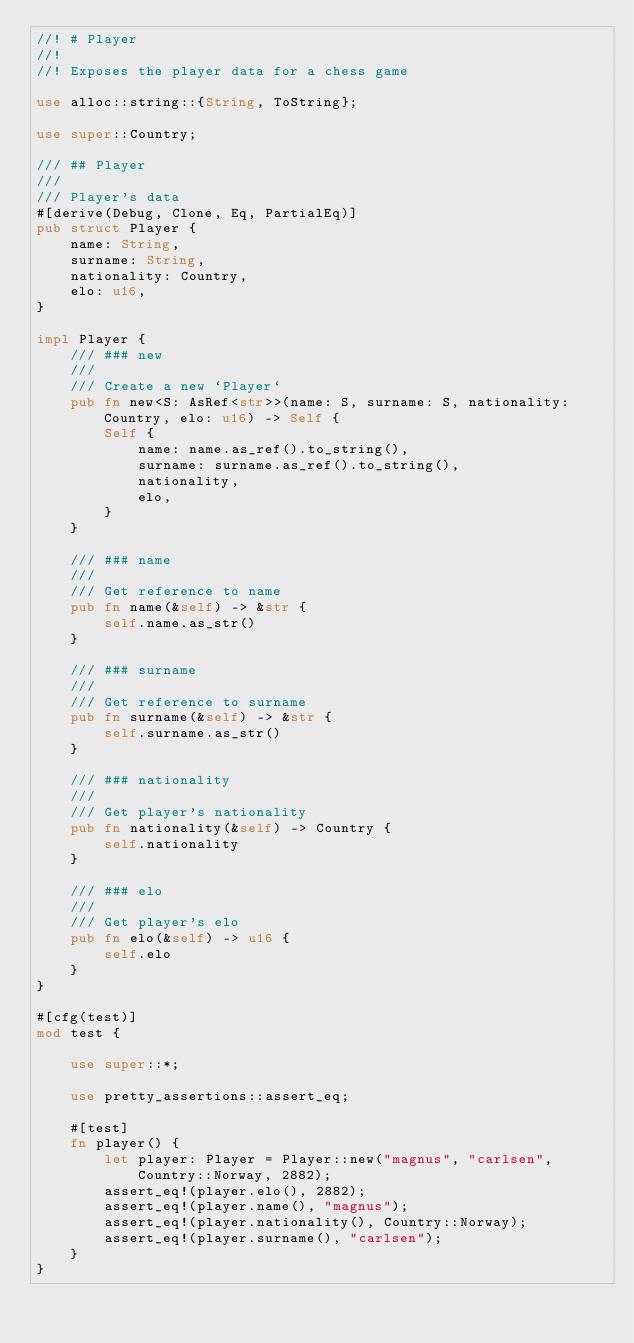Convert code to text. <code><loc_0><loc_0><loc_500><loc_500><_Rust_>//! # Player
//!
//! Exposes the player data for a chess game

use alloc::string::{String, ToString};

use super::Country;

/// ## Player
///
/// Player's data
#[derive(Debug, Clone, Eq, PartialEq)]
pub struct Player {
    name: String,
    surname: String,
    nationality: Country,
    elo: u16,
}

impl Player {
    /// ### new
    ///
    /// Create a new `Player`
    pub fn new<S: AsRef<str>>(name: S, surname: S, nationality: Country, elo: u16) -> Self {
        Self {
            name: name.as_ref().to_string(),
            surname: surname.as_ref().to_string(),
            nationality,
            elo,
        }
    }

    /// ### name
    ///
    /// Get reference to name
    pub fn name(&self) -> &str {
        self.name.as_str()
    }

    /// ### surname
    ///
    /// Get reference to surname
    pub fn surname(&self) -> &str {
        self.surname.as_str()
    }

    /// ### nationality
    ///
    /// Get player's nationality
    pub fn nationality(&self) -> Country {
        self.nationality
    }

    /// ### elo
    ///
    /// Get player's elo
    pub fn elo(&self) -> u16 {
        self.elo
    }
}

#[cfg(test)]
mod test {

    use super::*;

    use pretty_assertions::assert_eq;

    #[test]
    fn player() {
        let player: Player = Player::new("magnus", "carlsen", Country::Norway, 2882);
        assert_eq!(player.elo(), 2882);
        assert_eq!(player.name(), "magnus");
        assert_eq!(player.nationality(), Country::Norway);
        assert_eq!(player.surname(), "carlsen");
    }
}
</code> 